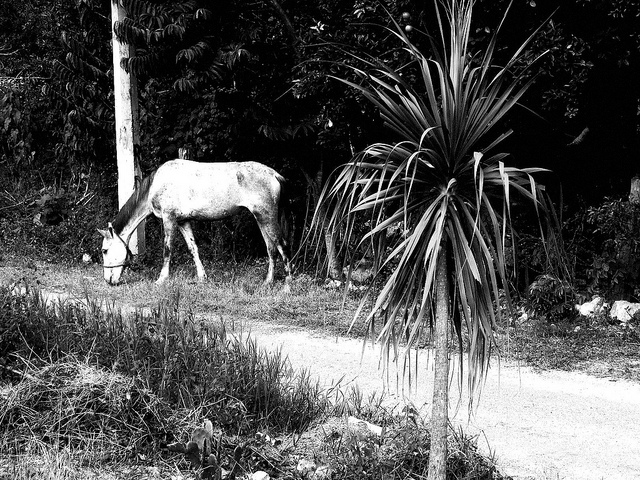How many people are wearing sunglasses? There are no people in the image, hence no one is wearing sunglasses. 